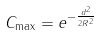Convert formula to latex. <formula><loc_0><loc_0><loc_500><loc_500>C _ { \max } = e ^ { - \frac { d ^ { 2 } } { 2 R ^ { 2 } } }</formula> 